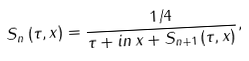<formula> <loc_0><loc_0><loc_500><loc_500>S _ { n } \left ( \tau , x \right ) = \frac { 1 / 4 } { \tau + i n \, x + S _ { n + 1 } \left ( \tau , x \right ) } ,</formula> 